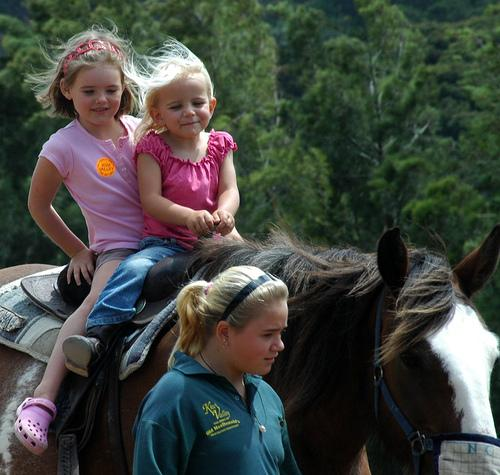What color is the person who is responsible for the safety of the two girls on horseback wearing?

Choices:
A) teal
B) black
C) pink
D) blue teal 